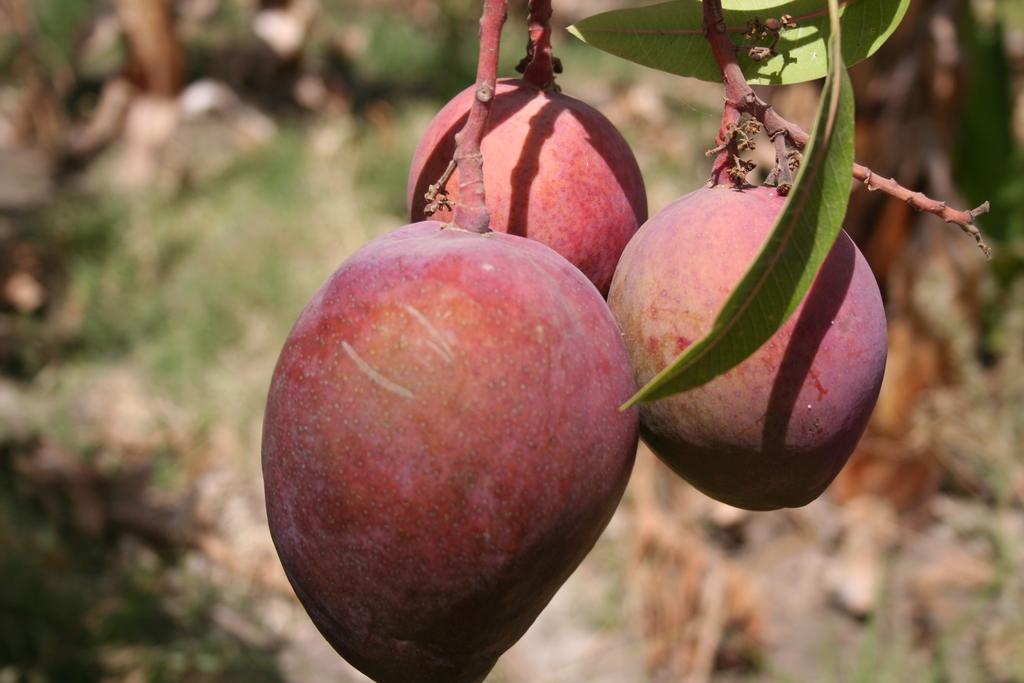Describe this image in one or two sentences. In this image I can see few fruits which are red and orange in color and few leaves which are green in color. I can see the blurry background. 